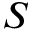Convert formula to latex. <formula><loc_0><loc_0><loc_500><loc_500>S</formula> 